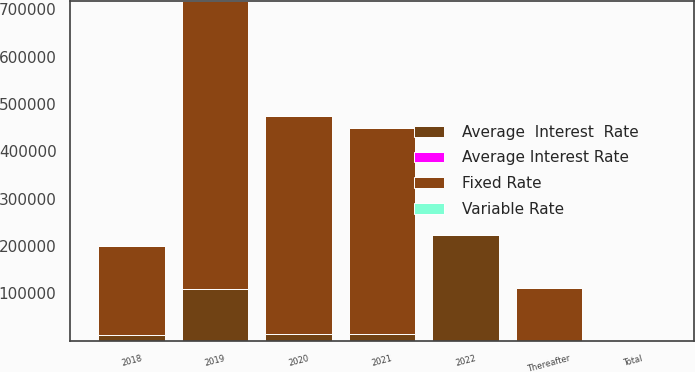Convert chart to OTSL. <chart><loc_0><loc_0><loc_500><loc_500><stacked_bar_chart><ecel><fcel>2018<fcel>2019<fcel>2020<fcel>2021<fcel>2022<fcel>Thereafter<fcel>Total<nl><fcel>Average  Interest  Rate<fcel>12491<fcel>108642<fcel>13584<fcel>14150<fcel>223299<fcel>4.93<fcel>4.93<nl><fcel>Variable Rate<fcel>4.04<fcel>4.04<fcel>4.04<fcel>4.04<fcel>3.99<fcel>3.88<fcel>4.03<nl><fcel>Fixed Rate<fcel>187759<fcel>609040<fcel>460225<fcel>435590<fcel>31<fcel>110384<fcel>4.93<nl><fcel>Average Interest Rate<fcel>3.74<fcel>4.21<fcel>4.63<fcel>4.93<fcel>5<fcel>4.63<fcel>4.25<nl></chart> 